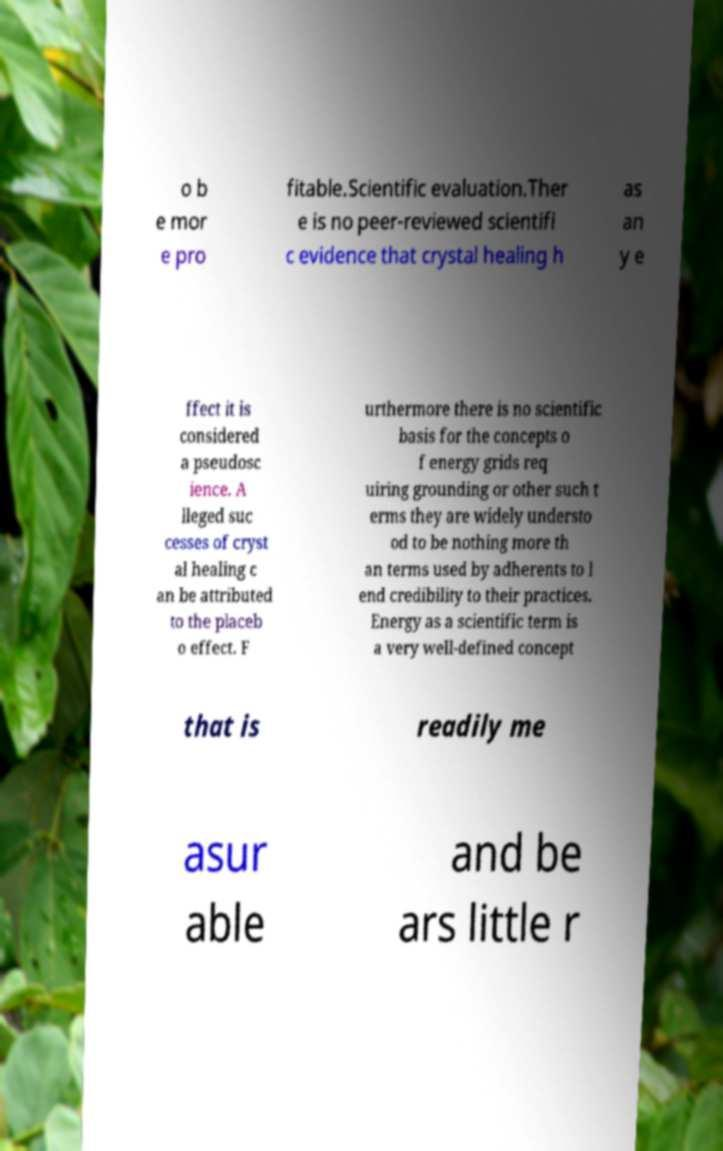Please read and relay the text visible in this image. What does it say? o b e mor e pro fitable.Scientific evaluation.Ther e is no peer-reviewed scientifi c evidence that crystal healing h as an y e ffect it is considered a pseudosc ience. A lleged suc cesses of cryst al healing c an be attributed to the placeb o effect. F urthermore there is no scientific basis for the concepts o f energy grids req uiring grounding or other such t erms they are widely understo od to be nothing more th an terms used by adherents to l end credibility to their practices. Energy as a scientific term is a very well-defined concept that is readily me asur able and be ars little r 